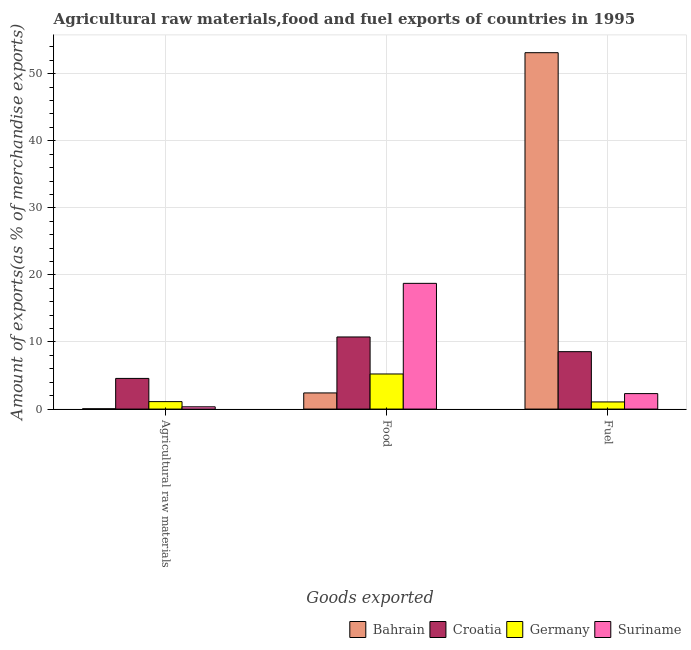How many different coloured bars are there?
Give a very brief answer. 4. Are the number of bars per tick equal to the number of legend labels?
Provide a succinct answer. Yes. Are the number of bars on each tick of the X-axis equal?
Offer a terse response. Yes. How many bars are there on the 3rd tick from the right?
Keep it short and to the point. 4. What is the label of the 2nd group of bars from the left?
Your response must be concise. Food. What is the percentage of fuel exports in Germany?
Offer a very short reply. 1.06. Across all countries, what is the maximum percentage of food exports?
Provide a succinct answer. 18.74. Across all countries, what is the minimum percentage of food exports?
Your response must be concise. 2.41. In which country was the percentage of raw materials exports maximum?
Your answer should be compact. Croatia. In which country was the percentage of food exports minimum?
Your answer should be very brief. Bahrain. What is the total percentage of raw materials exports in the graph?
Make the answer very short. 6.07. What is the difference between the percentage of raw materials exports in Suriname and that in Bahrain?
Ensure brevity in your answer.  0.3. What is the difference between the percentage of raw materials exports in Bahrain and the percentage of food exports in Croatia?
Provide a succinct answer. -10.71. What is the average percentage of food exports per country?
Ensure brevity in your answer.  9.28. What is the difference between the percentage of raw materials exports and percentage of food exports in Germany?
Your response must be concise. -4.12. In how many countries, is the percentage of raw materials exports greater than 38 %?
Your answer should be compact. 0. What is the ratio of the percentage of food exports in Croatia to that in Bahrain?
Keep it short and to the point. 4.47. Is the difference between the percentage of food exports in Bahrain and Germany greater than the difference between the percentage of raw materials exports in Bahrain and Germany?
Offer a very short reply. No. What is the difference between the highest and the second highest percentage of fuel exports?
Keep it short and to the point. 44.57. What is the difference between the highest and the lowest percentage of fuel exports?
Ensure brevity in your answer.  52.06. In how many countries, is the percentage of food exports greater than the average percentage of food exports taken over all countries?
Offer a terse response. 2. What does the 3rd bar from the left in Food represents?
Provide a succinct answer. Germany. How many countries are there in the graph?
Offer a terse response. 4. What is the difference between two consecutive major ticks on the Y-axis?
Keep it short and to the point. 10. Does the graph contain any zero values?
Provide a short and direct response. No. How many legend labels are there?
Your answer should be very brief. 4. What is the title of the graph?
Offer a very short reply. Agricultural raw materials,food and fuel exports of countries in 1995. What is the label or title of the X-axis?
Offer a very short reply. Goods exported. What is the label or title of the Y-axis?
Give a very brief answer. Amount of exports(as % of merchandise exports). What is the Amount of exports(as % of merchandise exports) in Bahrain in Agricultural raw materials?
Ensure brevity in your answer.  0.04. What is the Amount of exports(as % of merchandise exports) of Croatia in Agricultural raw materials?
Ensure brevity in your answer.  4.57. What is the Amount of exports(as % of merchandise exports) in Germany in Agricultural raw materials?
Ensure brevity in your answer.  1.11. What is the Amount of exports(as % of merchandise exports) in Suriname in Agricultural raw materials?
Provide a short and direct response. 0.34. What is the Amount of exports(as % of merchandise exports) of Bahrain in Food?
Keep it short and to the point. 2.41. What is the Amount of exports(as % of merchandise exports) in Croatia in Food?
Provide a short and direct response. 10.75. What is the Amount of exports(as % of merchandise exports) in Germany in Food?
Give a very brief answer. 5.23. What is the Amount of exports(as % of merchandise exports) in Suriname in Food?
Offer a terse response. 18.74. What is the Amount of exports(as % of merchandise exports) of Bahrain in Fuel?
Offer a terse response. 53.13. What is the Amount of exports(as % of merchandise exports) of Croatia in Fuel?
Ensure brevity in your answer.  8.56. What is the Amount of exports(as % of merchandise exports) in Germany in Fuel?
Ensure brevity in your answer.  1.06. What is the Amount of exports(as % of merchandise exports) of Suriname in Fuel?
Provide a succinct answer. 2.31. Across all Goods exported, what is the maximum Amount of exports(as % of merchandise exports) in Bahrain?
Ensure brevity in your answer.  53.13. Across all Goods exported, what is the maximum Amount of exports(as % of merchandise exports) in Croatia?
Provide a succinct answer. 10.75. Across all Goods exported, what is the maximum Amount of exports(as % of merchandise exports) in Germany?
Offer a terse response. 5.23. Across all Goods exported, what is the maximum Amount of exports(as % of merchandise exports) of Suriname?
Your answer should be very brief. 18.74. Across all Goods exported, what is the minimum Amount of exports(as % of merchandise exports) of Bahrain?
Provide a short and direct response. 0.04. Across all Goods exported, what is the minimum Amount of exports(as % of merchandise exports) in Croatia?
Offer a terse response. 4.57. Across all Goods exported, what is the minimum Amount of exports(as % of merchandise exports) in Germany?
Provide a succinct answer. 1.06. Across all Goods exported, what is the minimum Amount of exports(as % of merchandise exports) in Suriname?
Ensure brevity in your answer.  0.34. What is the total Amount of exports(as % of merchandise exports) of Bahrain in the graph?
Your response must be concise. 55.58. What is the total Amount of exports(as % of merchandise exports) in Croatia in the graph?
Offer a terse response. 23.88. What is the total Amount of exports(as % of merchandise exports) in Germany in the graph?
Your response must be concise. 7.41. What is the total Amount of exports(as % of merchandise exports) in Suriname in the graph?
Offer a terse response. 21.39. What is the difference between the Amount of exports(as % of merchandise exports) of Bahrain in Agricultural raw materials and that in Food?
Provide a short and direct response. -2.36. What is the difference between the Amount of exports(as % of merchandise exports) of Croatia in Agricultural raw materials and that in Food?
Your response must be concise. -6.18. What is the difference between the Amount of exports(as % of merchandise exports) in Germany in Agricultural raw materials and that in Food?
Make the answer very short. -4.12. What is the difference between the Amount of exports(as % of merchandise exports) of Suriname in Agricultural raw materials and that in Food?
Keep it short and to the point. -18.4. What is the difference between the Amount of exports(as % of merchandise exports) in Bahrain in Agricultural raw materials and that in Fuel?
Provide a succinct answer. -53.08. What is the difference between the Amount of exports(as % of merchandise exports) in Croatia in Agricultural raw materials and that in Fuel?
Make the answer very short. -3.99. What is the difference between the Amount of exports(as % of merchandise exports) in Germany in Agricultural raw materials and that in Fuel?
Give a very brief answer. 0.05. What is the difference between the Amount of exports(as % of merchandise exports) of Suriname in Agricultural raw materials and that in Fuel?
Your answer should be very brief. -1.97. What is the difference between the Amount of exports(as % of merchandise exports) in Bahrain in Food and that in Fuel?
Give a very brief answer. -50.72. What is the difference between the Amount of exports(as % of merchandise exports) in Croatia in Food and that in Fuel?
Your response must be concise. 2.19. What is the difference between the Amount of exports(as % of merchandise exports) of Germany in Food and that in Fuel?
Offer a terse response. 4.17. What is the difference between the Amount of exports(as % of merchandise exports) of Suriname in Food and that in Fuel?
Ensure brevity in your answer.  16.44. What is the difference between the Amount of exports(as % of merchandise exports) of Bahrain in Agricultural raw materials and the Amount of exports(as % of merchandise exports) of Croatia in Food?
Make the answer very short. -10.71. What is the difference between the Amount of exports(as % of merchandise exports) of Bahrain in Agricultural raw materials and the Amount of exports(as % of merchandise exports) of Germany in Food?
Provide a short and direct response. -5.19. What is the difference between the Amount of exports(as % of merchandise exports) of Bahrain in Agricultural raw materials and the Amount of exports(as % of merchandise exports) of Suriname in Food?
Provide a succinct answer. -18.7. What is the difference between the Amount of exports(as % of merchandise exports) of Croatia in Agricultural raw materials and the Amount of exports(as % of merchandise exports) of Germany in Food?
Provide a succinct answer. -0.66. What is the difference between the Amount of exports(as % of merchandise exports) in Croatia in Agricultural raw materials and the Amount of exports(as % of merchandise exports) in Suriname in Food?
Offer a very short reply. -14.17. What is the difference between the Amount of exports(as % of merchandise exports) of Germany in Agricultural raw materials and the Amount of exports(as % of merchandise exports) of Suriname in Food?
Ensure brevity in your answer.  -17.63. What is the difference between the Amount of exports(as % of merchandise exports) in Bahrain in Agricultural raw materials and the Amount of exports(as % of merchandise exports) in Croatia in Fuel?
Your response must be concise. -8.52. What is the difference between the Amount of exports(as % of merchandise exports) of Bahrain in Agricultural raw materials and the Amount of exports(as % of merchandise exports) of Germany in Fuel?
Keep it short and to the point. -1.02. What is the difference between the Amount of exports(as % of merchandise exports) in Bahrain in Agricultural raw materials and the Amount of exports(as % of merchandise exports) in Suriname in Fuel?
Ensure brevity in your answer.  -2.26. What is the difference between the Amount of exports(as % of merchandise exports) in Croatia in Agricultural raw materials and the Amount of exports(as % of merchandise exports) in Germany in Fuel?
Provide a succinct answer. 3.51. What is the difference between the Amount of exports(as % of merchandise exports) of Croatia in Agricultural raw materials and the Amount of exports(as % of merchandise exports) of Suriname in Fuel?
Make the answer very short. 2.27. What is the difference between the Amount of exports(as % of merchandise exports) of Germany in Agricultural raw materials and the Amount of exports(as % of merchandise exports) of Suriname in Fuel?
Offer a very short reply. -1.19. What is the difference between the Amount of exports(as % of merchandise exports) in Bahrain in Food and the Amount of exports(as % of merchandise exports) in Croatia in Fuel?
Provide a short and direct response. -6.15. What is the difference between the Amount of exports(as % of merchandise exports) in Bahrain in Food and the Amount of exports(as % of merchandise exports) in Germany in Fuel?
Give a very brief answer. 1.34. What is the difference between the Amount of exports(as % of merchandise exports) in Bahrain in Food and the Amount of exports(as % of merchandise exports) in Suriname in Fuel?
Provide a succinct answer. 0.1. What is the difference between the Amount of exports(as % of merchandise exports) in Croatia in Food and the Amount of exports(as % of merchandise exports) in Germany in Fuel?
Make the answer very short. 9.69. What is the difference between the Amount of exports(as % of merchandise exports) in Croatia in Food and the Amount of exports(as % of merchandise exports) in Suriname in Fuel?
Provide a short and direct response. 8.44. What is the difference between the Amount of exports(as % of merchandise exports) of Germany in Food and the Amount of exports(as % of merchandise exports) of Suriname in Fuel?
Offer a terse response. 2.93. What is the average Amount of exports(as % of merchandise exports) of Bahrain per Goods exported?
Offer a terse response. 18.53. What is the average Amount of exports(as % of merchandise exports) of Croatia per Goods exported?
Your response must be concise. 7.96. What is the average Amount of exports(as % of merchandise exports) of Germany per Goods exported?
Your answer should be very brief. 2.47. What is the average Amount of exports(as % of merchandise exports) of Suriname per Goods exported?
Offer a terse response. 7.13. What is the difference between the Amount of exports(as % of merchandise exports) of Bahrain and Amount of exports(as % of merchandise exports) of Croatia in Agricultural raw materials?
Provide a short and direct response. -4.53. What is the difference between the Amount of exports(as % of merchandise exports) in Bahrain and Amount of exports(as % of merchandise exports) in Germany in Agricultural raw materials?
Your answer should be very brief. -1.07. What is the difference between the Amount of exports(as % of merchandise exports) in Bahrain and Amount of exports(as % of merchandise exports) in Suriname in Agricultural raw materials?
Ensure brevity in your answer.  -0.3. What is the difference between the Amount of exports(as % of merchandise exports) in Croatia and Amount of exports(as % of merchandise exports) in Germany in Agricultural raw materials?
Your response must be concise. 3.46. What is the difference between the Amount of exports(as % of merchandise exports) in Croatia and Amount of exports(as % of merchandise exports) in Suriname in Agricultural raw materials?
Your answer should be very brief. 4.23. What is the difference between the Amount of exports(as % of merchandise exports) in Germany and Amount of exports(as % of merchandise exports) in Suriname in Agricultural raw materials?
Provide a succinct answer. 0.77. What is the difference between the Amount of exports(as % of merchandise exports) in Bahrain and Amount of exports(as % of merchandise exports) in Croatia in Food?
Your answer should be compact. -8.34. What is the difference between the Amount of exports(as % of merchandise exports) of Bahrain and Amount of exports(as % of merchandise exports) of Germany in Food?
Provide a succinct answer. -2.82. What is the difference between the Amount of exports(as % of merchandise exports) in Bahrain and Amount of exports(as % of merchandise exports) in Suriname in Food?
Make the answer very short. -16.34. What is the difference between the Amount of exports(as % of merchandise exports) in Croatia and Amount of exports(as % of merchandise exports) in Germany in Food?
Your response must be concise. 5.52. What is the difference between the Amount of exports(as % of merchandise exports) of Croatia and Amount of exports(as % of merchandise exports) of Suriname in Food?
Offer a terse response. -7.99. What is the difference between the Amount of exports(as % of merchandise exports) in Germany and Amount of exports(as % of merchandise exports) in Suriname in Food?
Offer a terse response. -13.51. What is the difference between the Amount of exports(as % of merchandise exports) in Bahrain and Amount of exports(as % of merchandise exports) in Croatia in Fuel?
Your answer should be very brief. 44.57. What is the difference between the Amount of exports(as % of merchandise exports) in Bahrain and Amount of exports(as % of merchandise exports) in Germany in Fuel?
Offer a very short reply. 52.06. What is the difference between the Amount of exports(as % of merchandise exports) of Bahrain and Amount of exports(as % of merchandise exports) of Suriname in Fuel?
Offer a very short reply. 50.82. What is the difference between the Amount of exports(as % of merchandise exports) in Croatia and Amount of exports(as % of merchandise exports) in Germany in Fuel?
Your answer should be very brief. 7.49. What is the difference between the Amount of exports(as % of merchandise exports) of Croatia and Amount of exports(as % of merchandise exports) of Suriname in Fuel?
Keep it short and to the point. 6.25. What is the difference between the Amount of exports(as % of merchandise exports) in Germany and Amount of exports(as % of merchandise exports) in Suriname in Fuel?
Ensure brevity in your answer.  -1.24. What is the ratio of the Amount of exports(as % of merchandise exports) in Bahrain in Agricultural raw materials to that in Food?
Make the answer very short. 0.02. What is the ratio of the Amount of exports(as % of merchandise exports) in Croatia in Agricultural raw materials to that in Food?
Provide a short and direct response. 0.43. What is the ratio of the Amount of exports(as % of merchandise exports) of Germany in Agricultural raw materials to that in Food?
Your answer should be compact. 0.21. What is the ratio of the Amount of exports(as % of merchandise exports) of Suriname in Agricultural raw materials to that in Food?
Provide a succinct answer. 0.02. What is the ratio of the Amount of exports(as % of merchandise exports) in Bahrain in Agricultural raw materials to that in Fuel?
Keep it short and to the point. 0. What is the ratio of the Amount of exports(as % of merchandise exports) of Croatia in Agricultural raw materials to that in Fuel?
Keep it short and to the point. 0.53. What is the ratio of the Amount of exports(as % of merchandise exports) of Germany in Agricultural raw materials to that in Fuel?
Make the answer very short. 1.04. What is the ratio of the Amount of exports(as % of merchandise exports) in Suriname in Agricultural raw materials to that in Fuel?
Your answer should be very brief. 0.15. What is the ratio of the Amount of exports(as % of merchandise exports) in Bahrain in Food to that in Fuel?
Your answer should be compact. 0.05. What is the ratio of the Amount of exports(as % of merchandise exports) of Croatia in Food to that in Fuel?
Keep it short and to the point. 1.26. What is the ratio of the Amount of exports(as % of merchandise exports) in Germany in Food to that in Fuel?
Offer a terse response. 4.91. What is the ratio of the Amount of exports(as % of merchandise exports) in Suriname in Food to that in Fuel?
Your answer should be very brief. 8.13. What is the difference between the highest and the second highest Amount of exports(as % of merchandise exports) of Bahrain?
Provide a short and direct response. 50.72. What is the difference between the highest and the second highest Amount of exports(as % of merchandise exports) in Croatia?
Offer a very short reply. 2.19. What is the difference between the highest and the second highest Amount of exports(as % of merchandise exports) in Germany?
Provide a succinct answer. 4.12. What is the difference between the highest and the second highest Amount of exports(as % of merchandise exports) of Suriname?
Make the answer very short. 16.44. What is the difference between the highest and the lowest Amount of exports(as % of merchandise exports) of Bahrain?
Give a very brief answer. 53.08. What is the difference between the highest and the lowest Amount of exports(as % of merchandise exports) of Croatia?
Your response must be concise. 6.18. What is the difference between the highest and the lowest Amount of exports(as % of merchandise exports) in Germany?
Offer a terse response. 4.17. What is the difference between the highest and the lowest Amount of exports(as % of merchandise exports) of Suriname?
Your response must be concise. 18.4. 